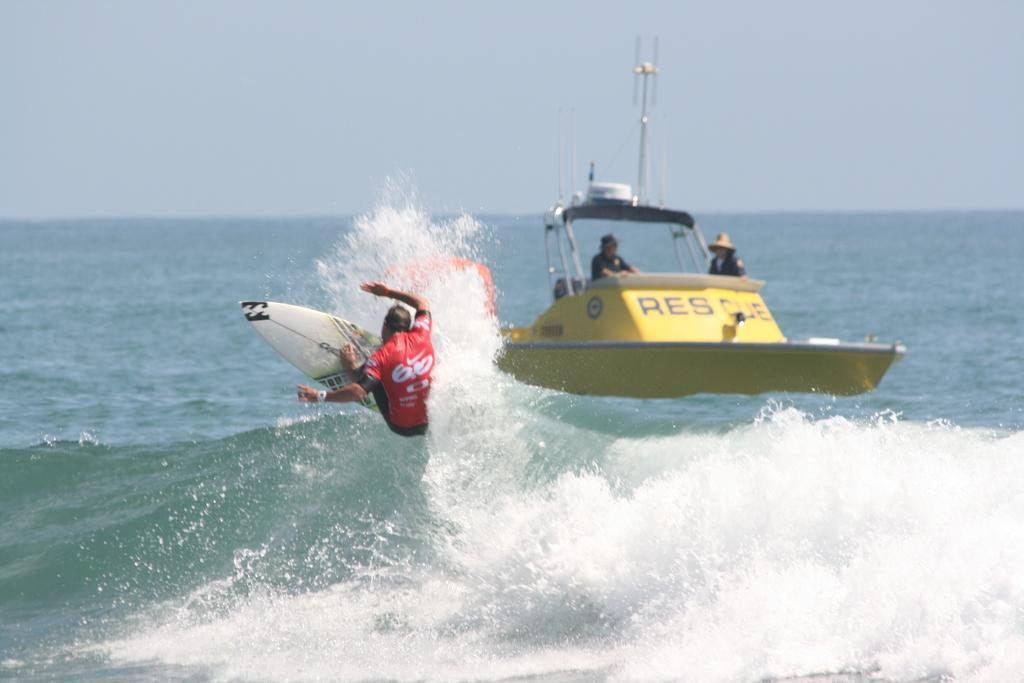<image>
Create a compact narrative representing the image presented. A small boat that says "rescue" on it is right near a surfer. 